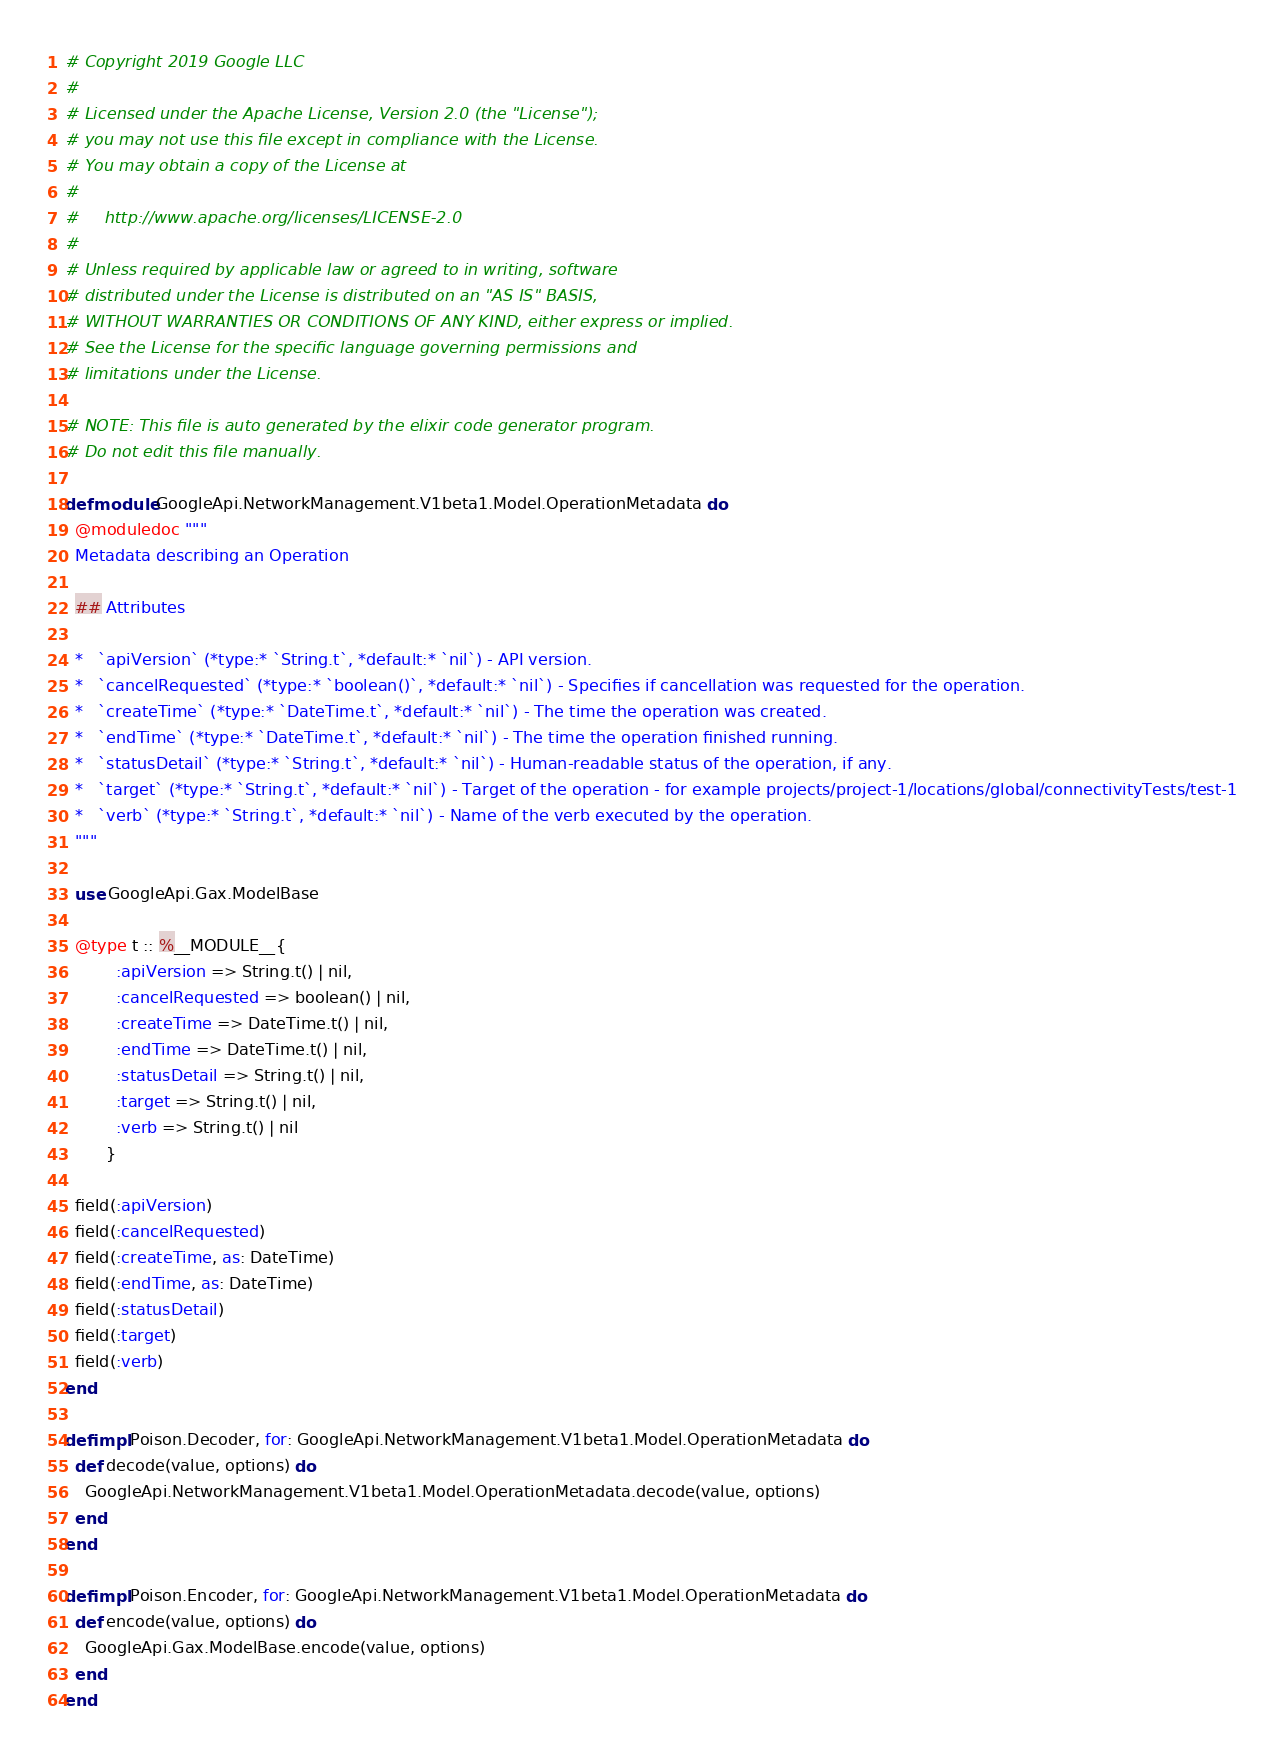<code> <loc_0><loc_0><loc_500><loc_500><_Elixir_># Copyright 2019 Google LLC
#
# Licensed under the Apache License, Version 2.0 (the "License");
# you may not use this file except in compliance with the License.
# You may obtain a copy of the License at
#
#     http://www.apache.org/licenses/LICENSE-2.0
#
# Unless required by applicable law or agreed to in writing, software
# distributed under the License is distributed on an "AS IS" BASIS,
# WITHOUT WARRANTIES OR CONDITIONS OF ANY KIND, either express or implied.
# See the License for the specific language governing permissions and
# limitations under the License.

# NOTE: This file is auto generated by the elixir code generator program.
# Do not edit this file manually.

defmodule GoogleApi.NetworkManagement.V1beta1.Model.OperationMetadata do
  @moduledoc """
  Metadata describing an Operation

  ## Attributes

  *   `apiVersion` (*type:* `String.t`, *default:* `nil`) - API version.
  *   `cancelRequested` (*type:* `boolean()`, *default:* `nil`) - Specifies if cancellation was requested for the operation.
  *   `createTime` (*type:* `DateTime.t`, *default:* `nil`) - The time the operation was created.
  *   `endTime` (*type:* `DateTime.t`, *default:* `nil`) - The time the operation finished running.
  *   `statusDetail` (*type:* `String.t`, *default:* `nil`) - Human-readable status of the operation, if any.
  *   `target` (*type:* `String.t`, *default:* `nil`) - Target of the operation - for example projects/project-1/locations/global/connectivityTests/test-1
  *   `verb` (*type:* `String.t`, *default:* `nil`) - Name of the verb executed by the operation.
  """

  use GoogleApi.Gax.ModelBase

  @type t :: %__MODULE__{
          :apiVersion => String.t() | nil,
          :cancelRequested => boolean() | nil,
          :createTime => DateTime.t() | nil,
          :endTime => DateTime.t() | nil,
          :statusDetail => String.t() | nil,
          :target => String.t() | nil,
          :verb => String.t() | nil
        }

  field(:apiVersion)
  field(:cancelRequested)
  field(:createTime, as: DateTime)
  field(:endTime, as: DateTime)
  field(:statusDetail)
  field(:target)
  field(:verb)
end

defimpl Poison.Decoder, for: GoogleApi.NetworkManagement.V1beta1.Model.OperationMetadata do
  def decode(value, options) do
    GoogleApi.NetworkManagement.V1beta1.Model.OperationMetadata.decode(value, options)
  end
end

defimpl Poison.Encoder, for: GoogleApi.NetworkManagement.V1beta1.Model.OperationMetadata do
  def encode(value, options) do
    GoogleApi.Gax.ModelBase.encode(value, options)
  end
end
</code> 